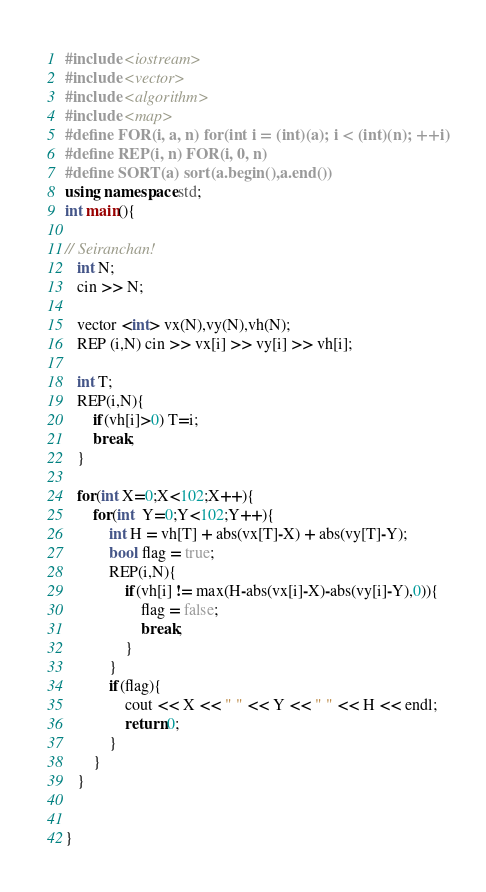<code> <loc_0><loc_0><loc_500><loc_500><_C++_>

#include <iostream>
#include <vector>
#include <algorithm>
#include <map>
#define FOR(i, a, n) for(int i = (int)(a); i < (int)(n); ++i)
#define REP(i, n) FOR(i, 0, n)
#define SORT(a) sort(a.begin(),a.end())
using namespace std;
int main(){

// Seiranchan!
   int N;
   cin >> N;

   vector <int> vx(N),vy(N),vh(N);
   REP (i,N) cin >> vx[i] >> vy[i] >> vh[i];

   int T;
   REP(i,N){
       if(vh[i]>0) T=i;
       break;
   }

   for(int X=0;X<102;X++){
       for(int  Y=0;Y<102;Y++){
           int H = vh[T] + abs(vx[T]-X) + abs(vy[T]-Y);
           bool flag = true;
           REP(i,N){
               if(vh[i] != max(H-abs(vx[i]-X)-abs(vy[i]-Y),0)){
                   flag = false;
                   break;
               }
           }
           if(flag){
               cout << X << " " << Y << " " << H << endl;
               return 0;
           }
       }
   }


}

</code> 